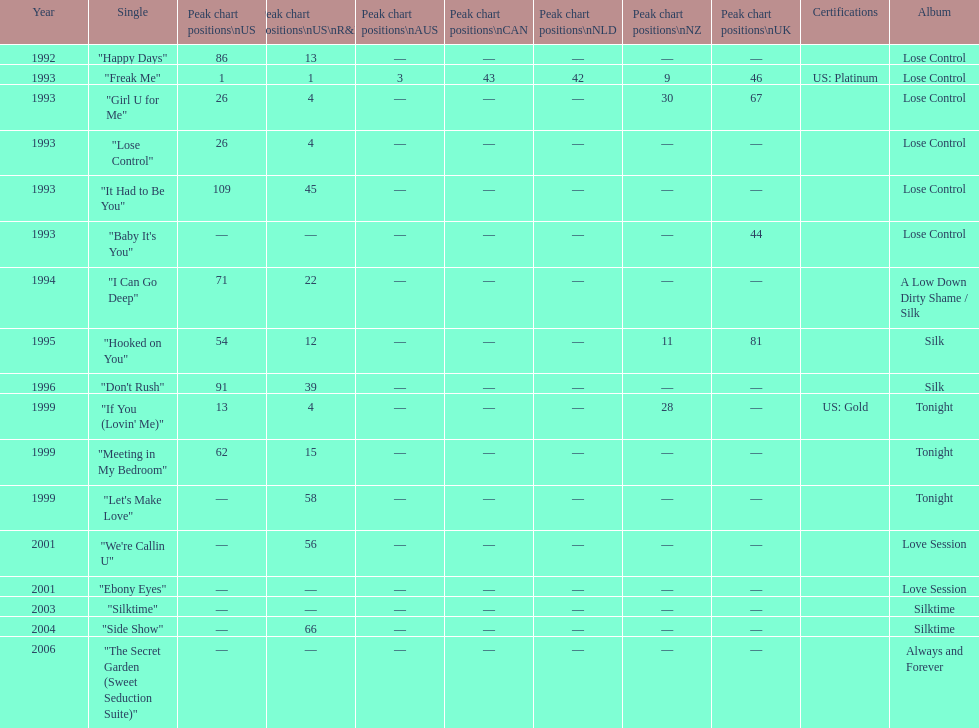Between "i can go deep" and "don't rush", which one had a higher position on the us and us r&b charts? "I Can Go Deep". 